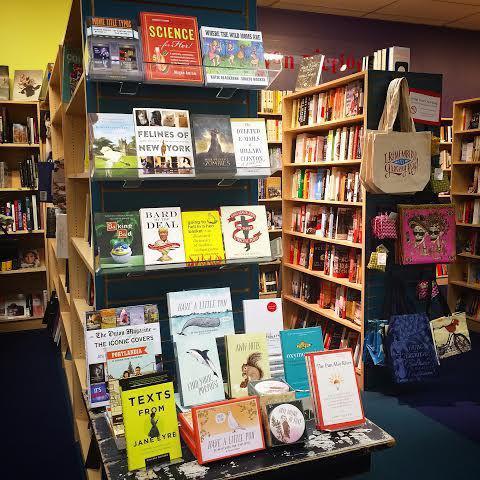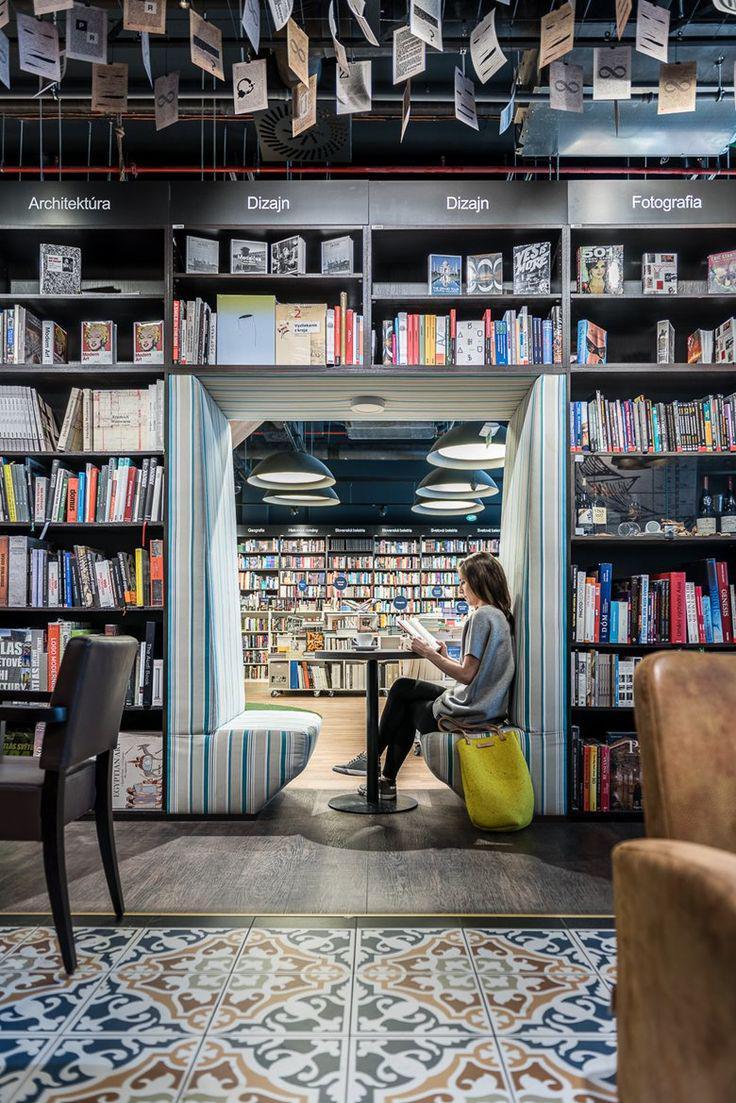The first image is the image on the left, the second image is the image on the right. Evaluate the accuracy of this statement regarding the images: "In the right image, a woman with a large handbag is framed by an opening between bookshelves.". Is it true? Answer yes or no. Yes. The first image is the image on the left, the second image is the image on the right. Given the left and right images, does the statement "At least two people are shopping for books." hold true? Answer yes or no. No. 